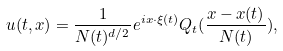<formula> <loc_0><loc_0><loc_500><loc_500>u ( t , x ) = \frac { 1 } { N ( t ) ^ { d / 2 } } e ^ { i x \cdot \xi ( t ) } Q _ { t } ( \frac { x - x ( t ) } { N ( t ) } ) ,</formula> 